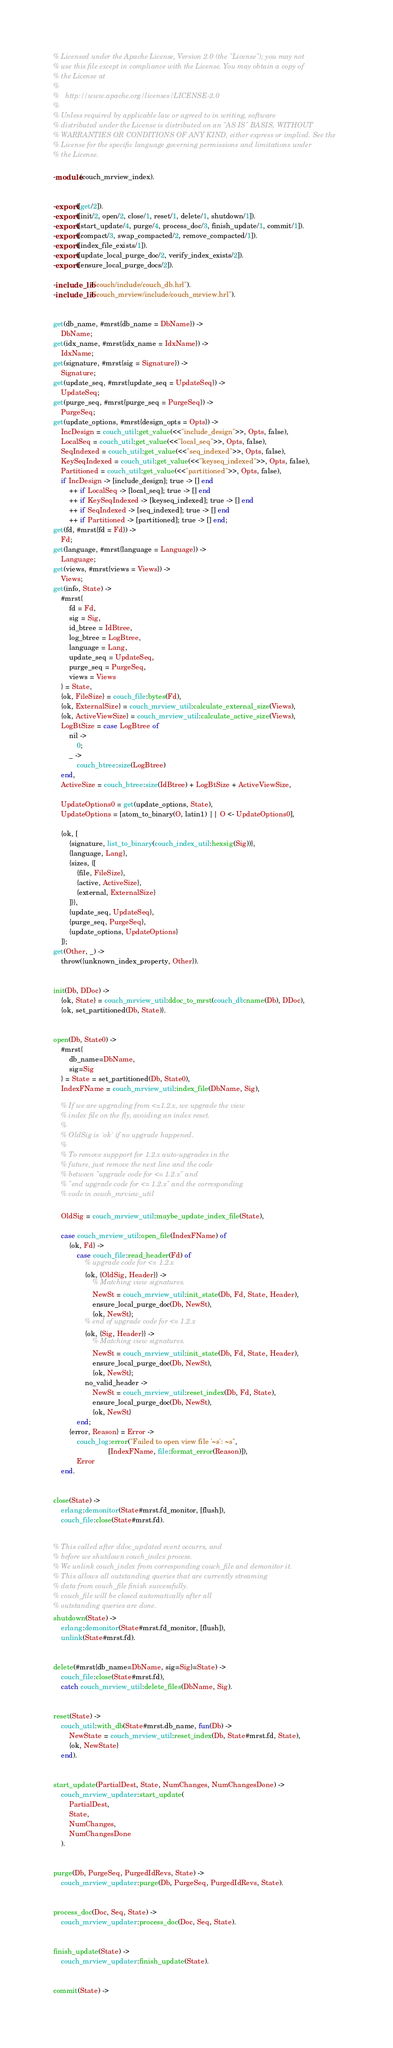<code> <loc_0><loc_0><loc_500><loc_500><_Erlang_>% Licensed under the Apache License, Version 2.0 (the "License"); you may not
% use this file except in compliance with the License. You may obtain a copy of
% the License at
%
%   http://www.apache.org/licenses/LICENSE-2.0
%
% Unless required by applicable law or agreed to in writing, software
% distributed under the License is distributed on an "AS IS" BASIS, WITHOUT
% WARRANTIES OR CONDITIONS OF ANY KIND, either express or implied. See the
% License for the specific language governing permissions and limitations under
% the License.

-module(couch_mrview_index).


-export([get/2]).
-export([init/2, open/2, close/1, reset/1, delete/1, shutdown/1]).
-export([start_update/4, purge/4, process_doc/3, finish_update/1, commit/1]).
-export([compact/3, swap_compacted/2, remove_compacted/1]).
-export([index_file_exists/1]).
-export([update_local_purge_doc/2, verify_index_exists/2]).
-export([ensure_local_purge_docs/2]).

-include_lib("couch/include/couch_db.hrl").
-include_lib("couch_mrview/include/couch_mrview.hrl").


get(db_name, #mrst{db_name = DbName}) ->
    DbName;
get(idx_name, #mrst{idx_name = IdxName}) ->
    IdxName;
get(signature, #mrst{sig = Signature}) ->
    Signature;
get(update_seq, #mrst{update_seq = UpdateSeq}) ->
    UpdateSeq;
get(purge_seq, #mrst{purge_seq = PurgeSeq}) ->
    PurgeSeq;
get(update_options, #mrst{design_opts = Opts}) ->
    IncDesign = couch_util:get_value(<<"include_design">>, Opts, false),
    LocalSeq = couch_util:get_value(<<"local_seq">>, Opts, false),
    SeqIndexed = couch_util:get_value(<<"seq_indexed">>, Opts, false),
    KeySeqIndexed = couch_util:get_value(<<"keyseq_indexed">>, Opts, false),
    Partitioned = couch_util:get_value(<<"partitioned">>, Opts, false),
    if IncDesign -> [include_design]; true -> [] end
        ++ if LocalSeq -> [local_seq]; true -> [] end
        ++ if KeySeqIndexed -> [keyseq_indexed]; true -> [] end
        ++ if SeqIndexed -> [seq_indexed]; true -> [] end
        ++ if Partitioned -> [partitioned]; true -> [] end;
get(fd, #mrst{fd = Fd}) ->
    Fd;
get(language, #mrst{language = Language}) ->
    Language;
get(views, #mrst{views = Views}) ->
    Views;
get(info, State) ->
    #mrst{
        fd = Fd,
        sig = Sig,
        id_btree = IdBtree,
        log_btree = LogBtree,
        language = Lang,
        update_seq = UpdateSeq,
        purge_seq = PurgeSeq,
        views = Views
    } = State,
    {ok, FileSize} = couch_file:bytes(Fd),
    {ok, ExternalSize} = couch_mrview_util:calculate_external_size(Views),
    {ok, ActiveViewSize} = couch_mrview_util:calculate_active_size(Views),
    LogBtSize = case LogBtree of
        nil ->
            0;
        _ ->
            couch_btree:size(LogBtree)
    end,
    ActiveSize = couch_btree:size(IdBtree) + LogBtSize + ActiveViewSize,

    UpdateOptions0 = get(update_options, State),
    UpdateOptions = [atom_to_binary(O, latin1) || O <- UpdateOptions0],

    {ok, [
        {signature, list_to_binary(couch_index_util:hexsig(Sig))},
        {language, Lang},
        {sizes, {[
            {file, FileSize},
            {active, ActiveSize},
            {external, ExternalSize}
        ]}},
        {update_seq, UpdateSeq},
        {purge_seq, PurgeSeq},
        {update_options, UpdateOptions}
    ]};
get(Other, _) ->
    throw({unknown_index_property, Other}).


init(Db, DDoc) ->
    {ok, State} = couch_mrview_util:ddoc_to_mrst(couch_db:name(Db), DDoc),
    {ok, set_partitioned(Db, State)}.


open(Db, State0) ->
    #mrst{
        db_name=DbName,
        sig=Sig
    } = State = set_partitioned(Db, State0),
    IndexFName = couch_mrview_util:index_file(DbName, Sig),

    % If we are upgrading from <=1.2.x, we upgrade the view
    % index file on the fly, avoiding an index reset.
    %
    % OldSig is `ok` if no upgrade happened.
    %
    % To remove suppport for 1.2.x auto-upgrades in the
    % future, just remove the next line and the code
    % between "upgrade code for <= 1.2.x" and
    % "end upgrade code for <= 1.2.x" and the corresponding
    % code in couch_mrview_util

    OldSig = couch_mrview_util:maybe_update_index_file(State),

    case couch_mrview_util:open_file(IndexFName) of
        {ok, Fd} ->
            case couch_file:read_header(Fd) of
                % upgrade code for <= 1.2.x
                {ok, {OldSig, Header}} ->
                    % Matching view signatures.
                    NewSt = couch_mrview_util:init_state(Db, Fd, State, Header),
                    ensure_local_purge_doc(Db, NewSt),
                    {ok, NewSt};
                % end of upgrade code for <= 1.2.x
                {ok, {Sig, Header}} ->
                    % Matching view signatures.
                    NewSt = couch_mrview_util:init_state(Db, Fd, State, Header),
                    ensure_local_purge_doc(Db, NewSt),
                    {ok, NewSt};
                no_valid_header ->
                    NewSt = couch_mrview_util:reset_index(Db, Fd, State),
                    ensure_local_purge_doc(Db, NewSt),
                    {ok, NewSt}
            end;
        {error, Reason} = Error ->
            couch_log:error("Failed to open view file '~s': ~s",
                            [IndexFName, file:format_error(Reason)]),
            Error
    end.


close(State) ->
    erlang:demonitor(State#mrst.fd_monitor, [flush]),
    couch_file:close(State#mrst.fd).


% This called after ddoc_updated event occurrs, and
% before we shutdown couch_index process.
% We unlink couch_index from corresponding couch_file and demonitor it.
% This allows all outstanding queries that are currently streaming
% data from couch_file finish successfully.
% couch_file will be closed automatically after all
% outstanding queries are done.
shutdown(State) ->
    erlang:demonitor(State#mrst.fd_monitor, [flush]),
    unlink(State#mrst.fd).


delete(#mrst{db_name=DbName, sig=Sig}=State) ->
    couch_file:close(State#mrst.fd),
    catch couch_mrview_util:delete_files(DbName, Sig).


reset(State) ->
    couch_util:with_db(State#mrst.db_name, fun(Db) ->
        NewState = couch_mrview_util:reset_index(Db, State#mrst.fd, State),
        {ok, NewState}
    end).


start_update(PartialDest, State, NumChanges, NumChangesDone) ->
    couch_mrview_updater:start_update(
        PartialDest,
        State,
        NumChanges,
        NumChangesDone
    ).


purge(Db, PurgeSeq, PurgedIdRevs, State) ->
    couch_mrview_updater:purge(Db, PurgeSeq, PurgedIdRevs, State).


process_doc(Doc, Seq, State) ->
    couch_mrview_updater:process_doc(Doc, Seq, State).


finish_update(State) ->
    couch_mrview_updater:finish_update(State).


commit(State) -></code> 